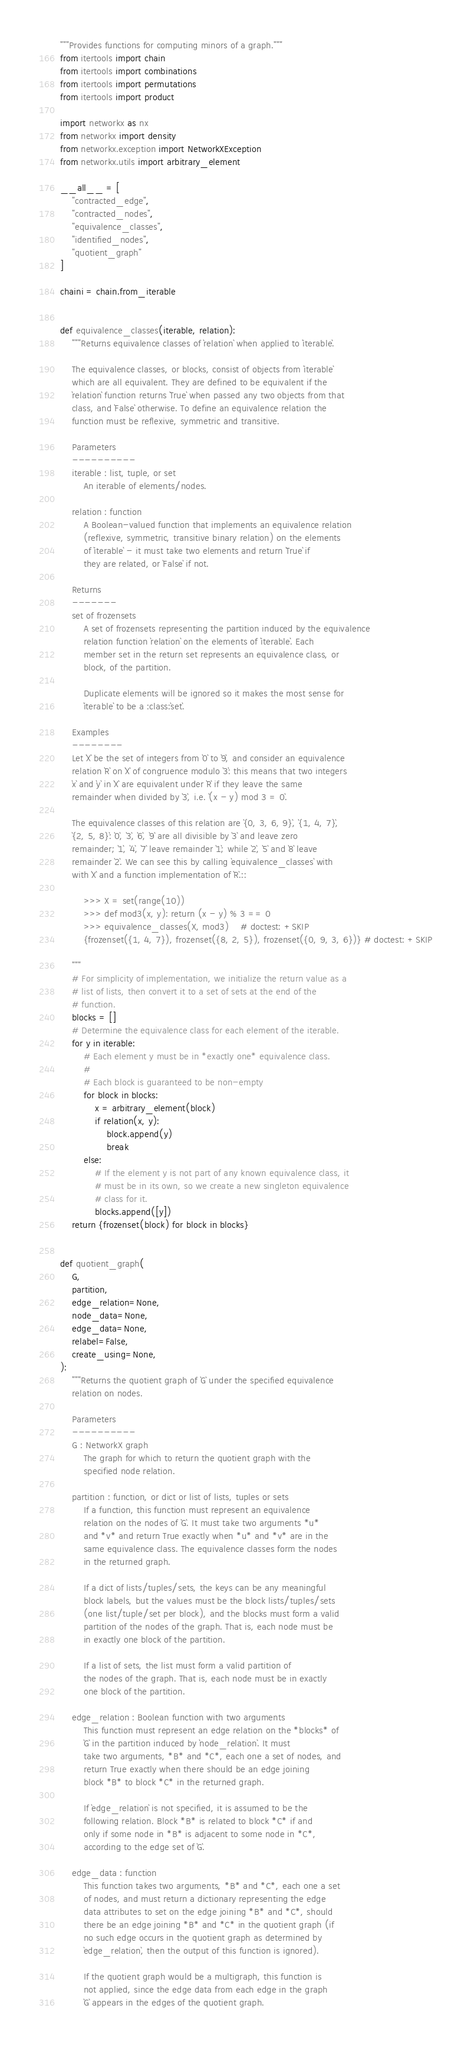Convert code to text. <code><loc_0><loc_0><loc_500><loc_500><_Python_>"""Provides functions for computing minors of a graph."""
from itertools import chain
from itertools import combinations
from itertools import permutations
from itertools import product

import networkx as nx
from networkx import density
from networkx.exception import NetworkXException
from networkx.utils import arbitrary_element

__all__ = [
    "contracted_edge",
    "contracted_nodes",
    "equivalence_classes",
    "identified_nodes",
    "quotient_graph"
]

chaini = chain.from_iterable


def equivalence_classes(iterable, relation):
    """Returns equivalence classes of `relation` when applied to `iterable`.

    The equivalence classes, or blocks, consist of objects from `iterable`
    which are all equivalent. They are defined to be equivalent if the
    `relation` function returns `True` when passed any two objects from that
    class, and `False` otherwise. To define an equivalence relation the
    function must be reflexive, symmetric and transitive.

    Parameters
    ----------
    iterable : list, tuple, or set
        An iterable of elements/nodes.

    relation : function
        A Boolean-valued function that implements an equivalence relation
        (reflexive, symmetric, transitive binary relation) on the elements
        of `iterable` - it must take two elements and return `True` if
        they are related, or `False` if not.

    Returns
    -------
    set of frozensets
        A set of frozensets representing the partition induced by the equivalence
        relation function `relation` on the elements of `iterable`. Each
        member set in the return set represents an equivalence class, or
        block, of the partition.

        Duplicate elements will be ignored so it makes the most sense for
        `iterable` to be a :class:`set`.

    Examples
    --------
    Let `X` be the set of integers from `0` to `9`, and consider an equivalence
    relation `R` on `X` of congruence modulo `3`: this means that two integers
    `x` and `y` in `X` are equivalent under `R` if they leave the same
    remainder when divided by `3`, i.e. `(x - y) mod 3 = 0`.

    The equivalence classes of this relation are `{0, 3, 6, 9}`, `{1, 4, 7}`,
    `{2, 5, 8}`: `0`, `3`, `6`, `9` are all divisible by `3` and leave zero
    remainder; `1`, `4`, `7` leave remainder `1`; while `2`, `5` and `8` leave
    remainder `2`. We can see this by calling `equivalence_classes` with
    with `X` and a function implementation of `R`.::

        >>> X = set(range(10))
        >>> def mod3(x, y): return (x - y) % 3 == 0
        >>> equivalence_classes(X, mod3)    # doctest: +SKIP
        {frozenset({1, 4, 7}), frozenset({8, 2, 5}), frozenset({0, 9, 3, 6})} # doctest: +SKIP

    """
    # For simplicity of implementation, we initialize the return value as a
    # list of lists, then convert it to a set of sets at the end of the
    # function.
    blocks = []
    # Determine the equivalence class for each element of the iterable.
    for y in iterable:
        # Each element y must be in *exactly one* equivalence class.
        #
        # Each block is guaranteed to be non-empty
        for block in blocks:
            x = arbitrary_element(block)
            if relation(x, y):
                block.append(y)
                break
        else:
            # If the element y is not part of any known equivalence class, it
            # must be in its own, so we create a new singleton equivalence
            # class for it.
            blocks.append([y])
    return {frozenset(block) for block in blocks}


def quotient_graph(
    G,
    partition,
    edge_relation=None,
    node_data=None,
    edge_data=None,
    relabel=False,
    create_using=None,
):
    """Returns the quotient graph of `G` under the specified equivalence
    relation on nodes.

    Parameters
    ----------
    G : NetworkX graph
        The graph for which to return the quotient graph with the
        specified node relation.

    partition : function, or dict or list of lists, tuples or sets
        If a function, this function must represent an equivalence
        relation on the nodes of `G`. It must take two arguments *u*
        and *v* and return True exactly when *u* and *v* are in the
        same equivalence class. The equivalence classes form the nodes
        in the returned graph.

        If a dict of lists/tuples/sets, the keys can be any meaningful
        block labels, but the values must be the block lists/tuples/sets
        (one list/tuple/set per block), and the blocks must form a valid
        partition of the nodes of the graph. That is, each node must be
        in exactly one block of the partition.

        If a list of sets, the list must form a valid partition of
        the nodes of the graph. That is, each node must be in exactly
        one block of the partition.

    edge_relation : Boolean function with two arguments
        This function must represent an edge relation on the *blocks* of
        `G` in the partition induced by `node_relation`. It must
        take two arguments, *B* and *C*, each one a set of nodes, and
        return True exactly when there should be an edge joining
        block *B* to block *C* in the returned graph.

        If `edge_relation` is not specified, it is assumed to be the
        following relation. Block *B* is related to block *C* if and
        only if some node in *B* is adjacent to some node in *C*,
        according to the edge set of `G`.

    edge_data : function
        This function takes two arguments, *B* and *C*, each one a set
        of nodes, and must return a dictionary representing the edge
        data attributes to set on the edge joining *B* and *C*, should
        there be an edge joining *B* and *C* in the quotient graph (if
        no such edge occurs in the quotient graph as determined by
        `edge_relation`, then the output of this function is ignored).

        If the quotient graph would be a multigraph, this function is
        not applied, since the edge data from each edge in the graph
        `G` appears in the edges of the quotient graph.
</code> 